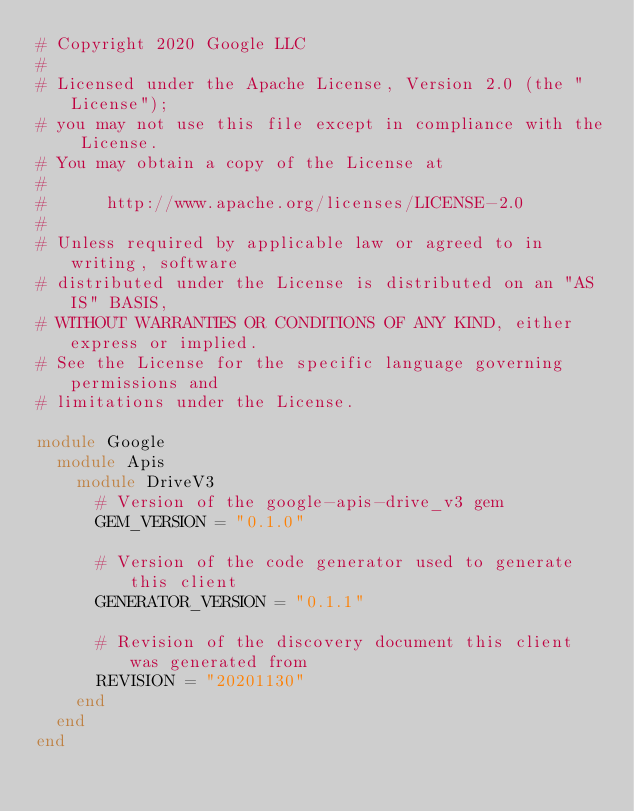Convert code to text. <code><loc_0><loc_0><loc_500><loc_500><_Ruby_># Copyright 2020 Google LLC
#
# Licensed under the Apache License, Version 2.0 (the "License");
# you may not use this file except in compliance with the License.
# You may obtain a copy of the License at
#
#      http://www.apache.org/licenses/LICENSE-2.0
#
# Unless required by applicable law or agreed to in writing, software
# distributed under the License is distributed on an "AS IS" BASIS,
# WITHOUT WARRANTIES OR CONDITIONS OF ANY KIND, either express or implied.
# See the License for the specific language governing permissions and
# limitations under the License.

module Google
  module Apis
    module DriveV3
      # Version of the google-apis-drive_v3 gem
      GEM_VERSION = "0.1.0"

      # Version of the code generator used to generate this client
      GENERATOR_VERSION = "0.1.1"

      # Revision of the discovery document this client was generated from
      REVISION = "20201130"
    end
  end
end
</code> 